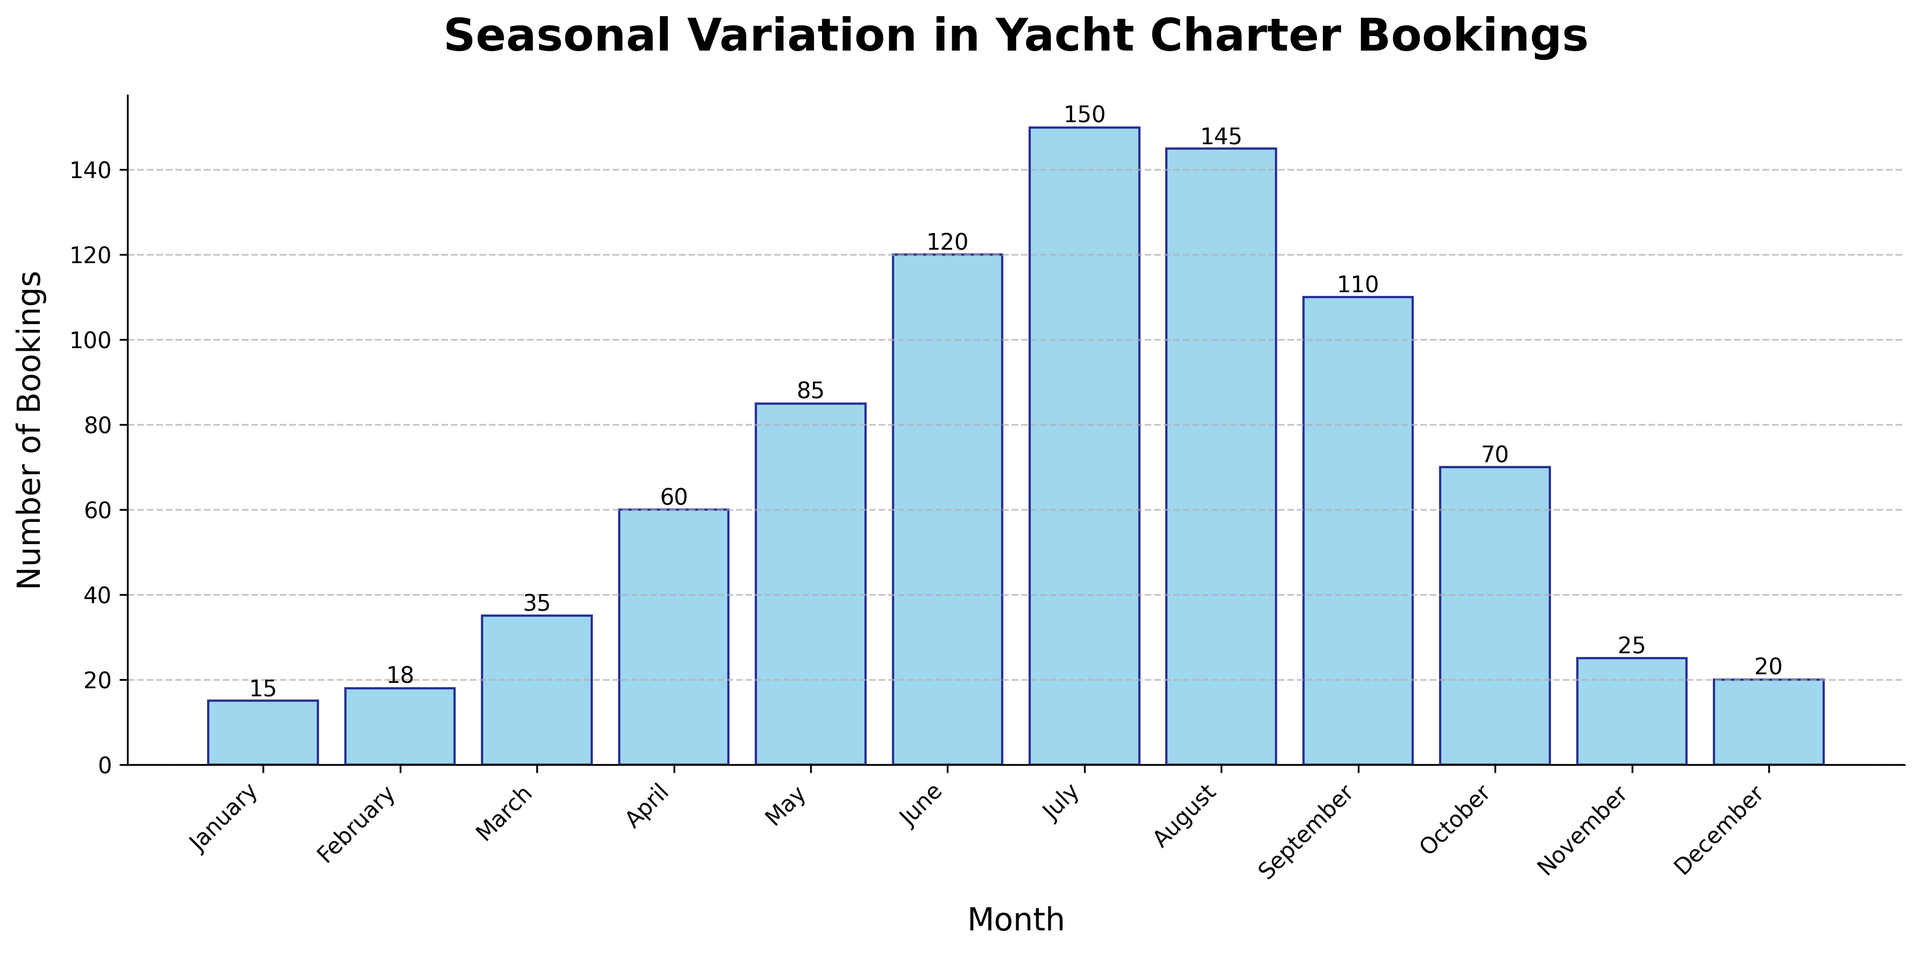Which month has the highest number of yacht charter bookings? Look at the height of the bars; the tallest bar represents July, suggesting it has the highest number of bookings.
Answer: July In which month are the yacht charter bookings the lowest? The shortest bar on the histogram represents January, indicating it has the lowest number of bookings.
Answer: January What is the total number of bookings in the summer months (June, July, August)? Sum the number of bookings for June, July, and August: 120 + 150 + 145 = 415.
Answer: 415 How does the number of bookings in October compare to those in March? Compare the heights of the bars for October and March. October has 70 bookings and March has 35 bookings. October has more bookings.
Answer: October has more bookings What is the average number of bookings across all months? Sum all the bookings and divide by the number of months. (15 + 18 + 35 + 60 + 85 + 120 + 150 + 145 + 110 + 70 + 25 + 20) / 12 = 71.25.
Answer: 71.25 How many more bookings were made in July compared to January? Subtract the number of bookings in January from the bookings in July: 150 - 15 = 135.
Answer: 135 Are there any two consecutive months where the bookings are equal? None of the bars have the same height when checked for consecutive months.
Answer: No Which quarter of the year has the most bookings (Q1: Jan-Mar, Q2: Apr-Jun, Q3: Jul-Sep, Q4: Oct-Dec)? Sum the bookings per quarter and compare: Q1 (Jan-Mar) = 68, Q2 (Apr-Jun) = 265, Q3 (Jul-Sep) = 405, Q4 (Oct-Dec) = 115. Q3 has the most bookings.
Answer: Q3 Between which two consecutive months is the largest increase in bookings observed? Compare the difference in bookings between each pair of consecutive months. The largest increase is from May to June (120-85=35).
Answer: May to June How does November compare to the average number of bookings across the year? The average number of bookings is 71.25. November has 25 bookings, which is less than the average.
Answer: Less than the average 